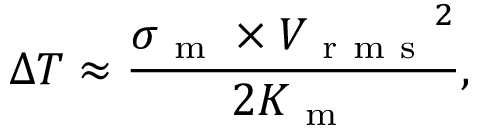<formula> <loc_0><loc_0><loc_500><loc_500>\Delta T \approx \frac { \sigma _ { m } \times { V _ { r m s } } ^ { 2 } } { 2 K _ { m } } ,</formula> 